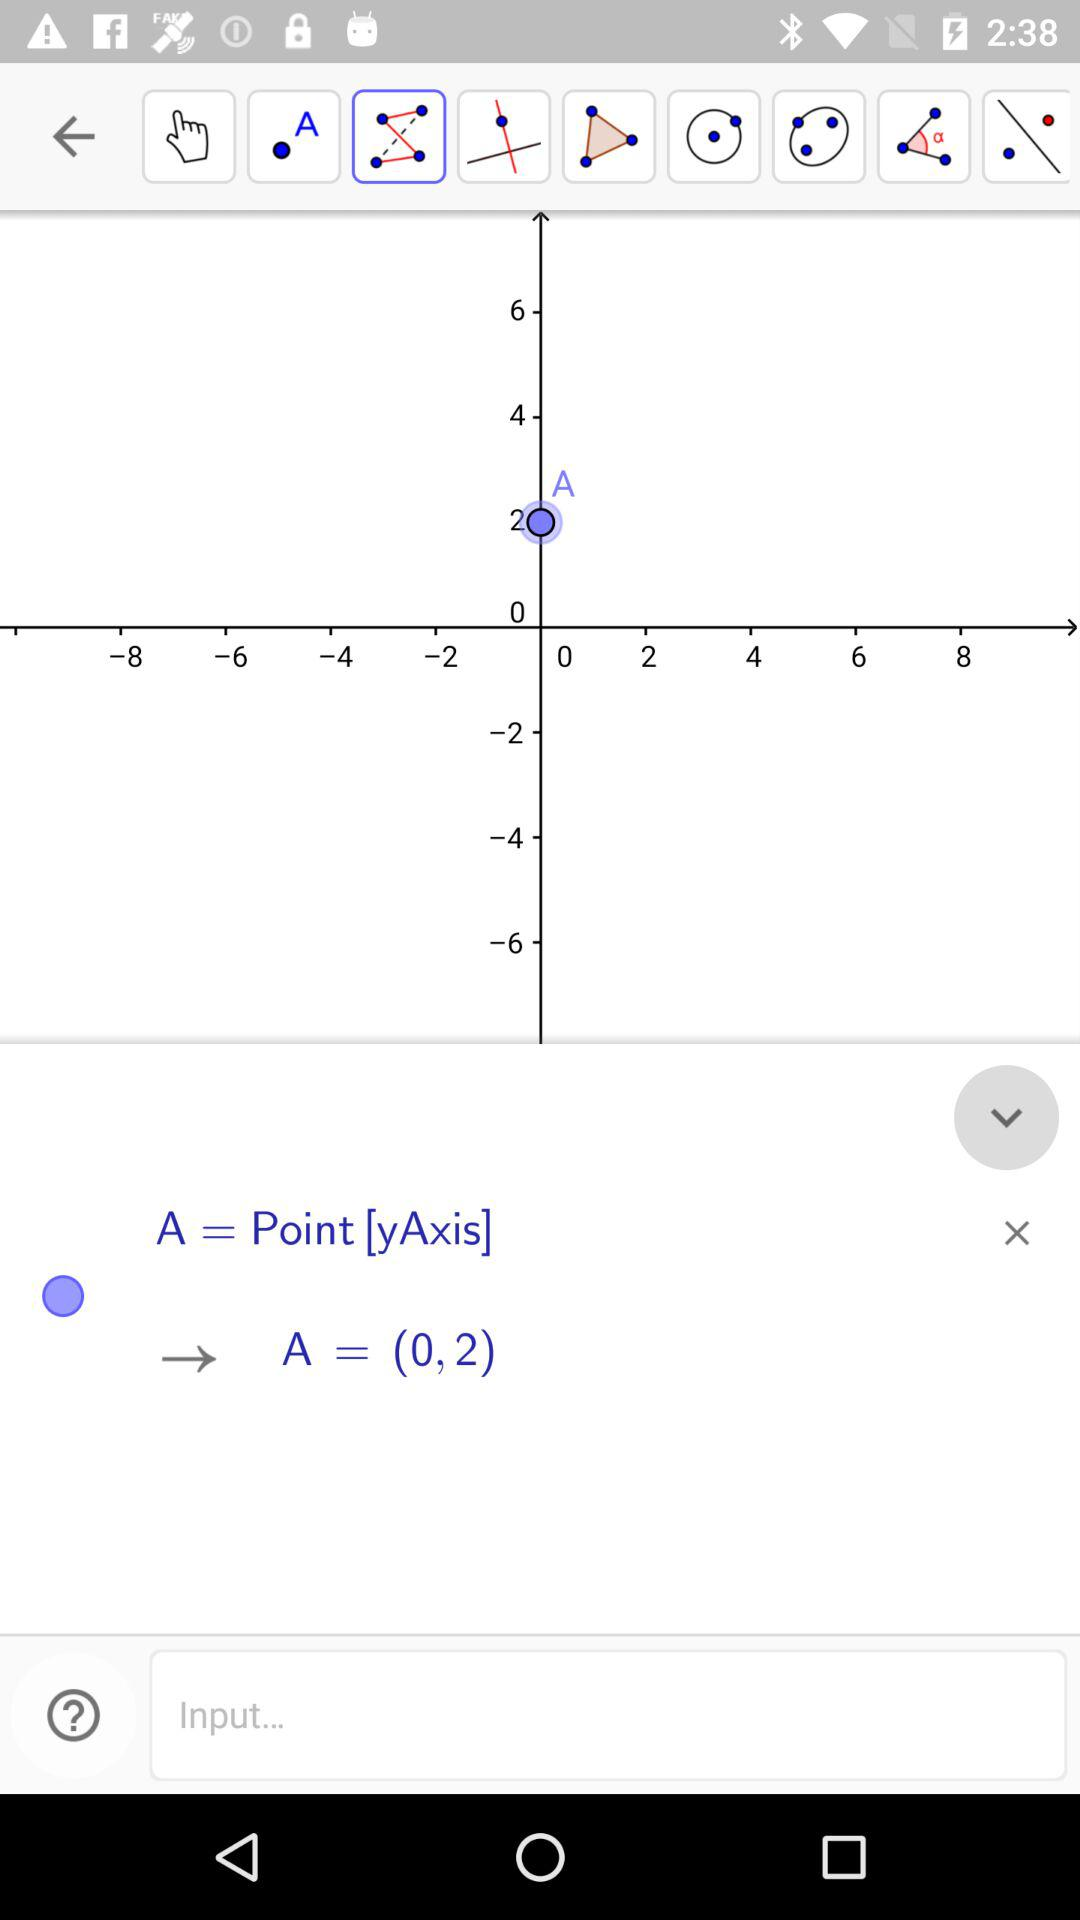What are the coordinates of point A? The coordinates of point A are 0 and 2. 